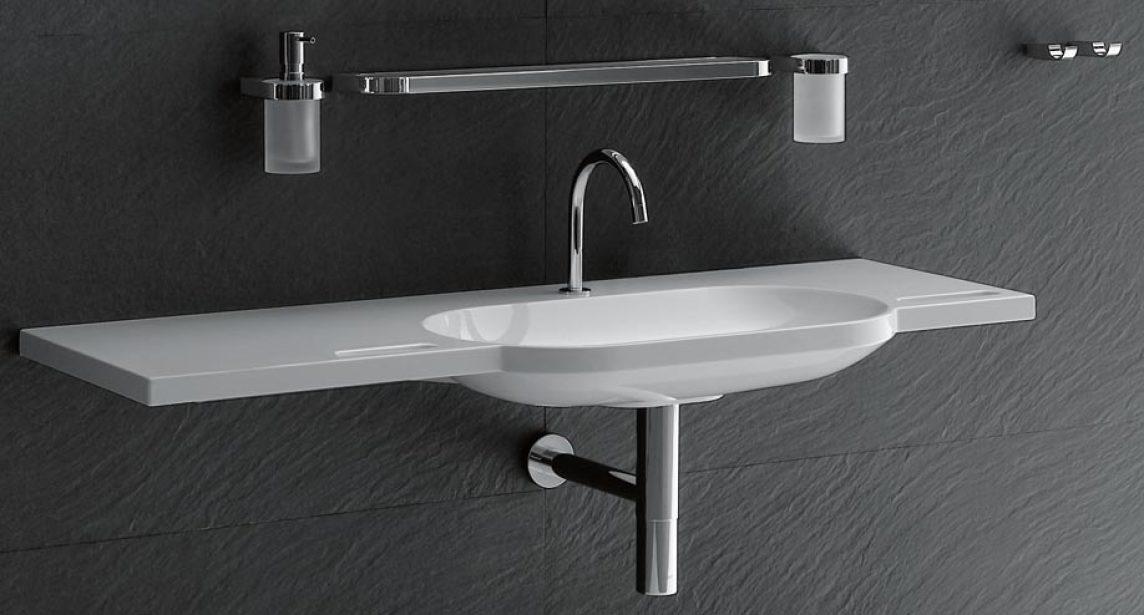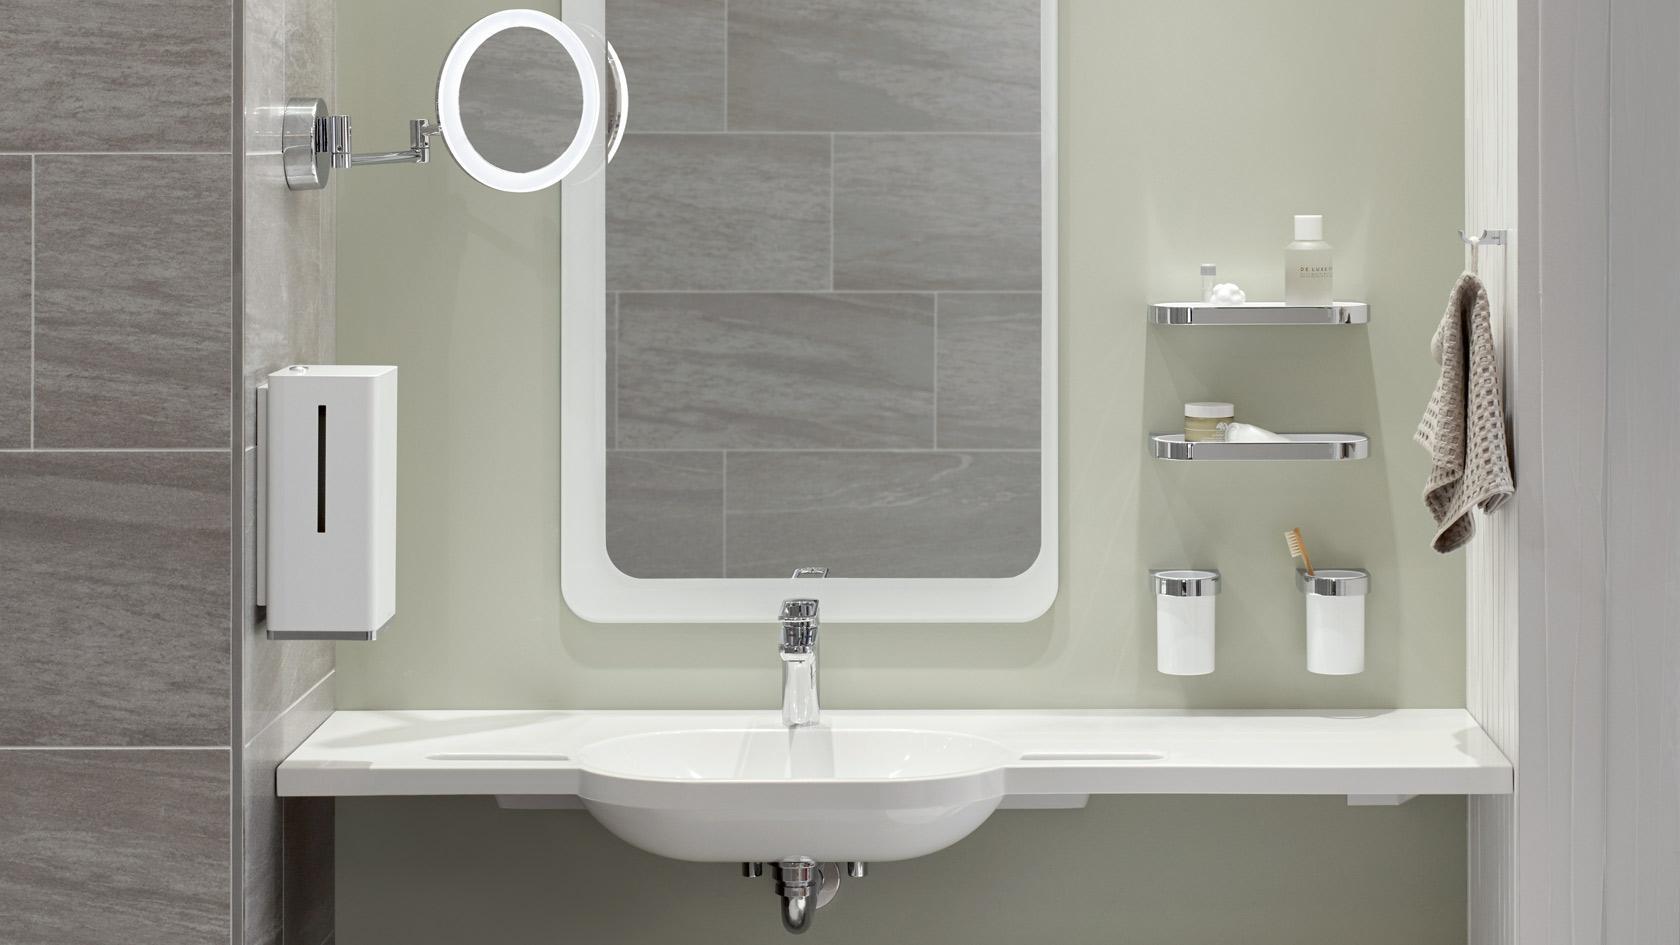The first image is the image on the left, the second image is the image on the right. Given the left and right images, does the statement "In one image, a wall-mounted bathroom sink with underside visible is shown with a wall mounted mirror, shaving mirror, and two toothbrush holders." hold true? Answer yes or no. Yes. The first image is the image on the left, the second image is the image on the right. Analyze the images presented: Is the assertion "One image includes a small round vanity mirror projecting from the wall next to a larger mirror above an oblong sink inset in a narrow, plank-like counter." valid? Answer yes or no. Yes. 